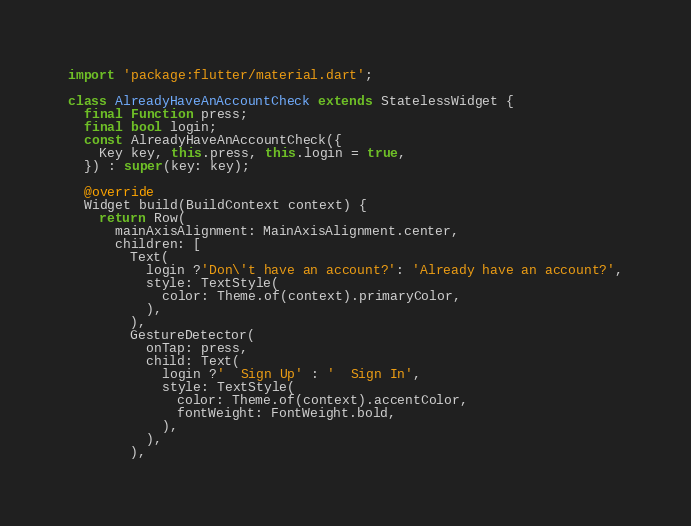Convert code to text. <code><loc_0><loc_0><loc_500><loc_500><_Dart_>import 'package:flutter/material.dart';

class AlreadyHaveAnAccountCheck extends StatelessWidget {
  final Function press;
  final bool login;
  const AlreadyHaveAnAccountCheck({
    Key key, this.press, this.login = true,
  }) : super(key: key);

  @override
  Widget build(BuildContext context) {
    return Row(
      mainAxisAlignment: MainAxisAlignment.center,
      children: [
        Text(
          login ?'Don\'t have an account?': 'Already have an account?',
          style: TextStyle(
            color: Theme.of(context).primaryColor,
          ),
        ),
        GestureDetector(
          onTap: press,
          child: Text(
            login ?'  Sign Up' : '  Sign In',
            style: TextStyle(
              color: Theme.of(context).accentColor,
              fontWeight: FontWeight.bold,
            ),
          ),
        ),</code> 